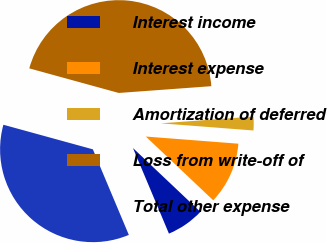Convert chart to OTSL. <chart><loc_0><loc_0><loc_500><loc_500><pie_chart><fcel>Interest income<fcel>Interest expense<fcel>Amortization of deferred<fcel>Loss from write-off of<fcel>Total other expense<nl><fcel>6.61%<fcel>10.83%<fcel>2.39%<fcel>44.57%<fcel>35.6%<nl></chart> 